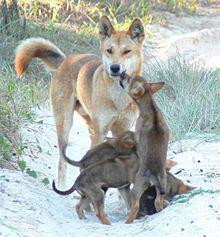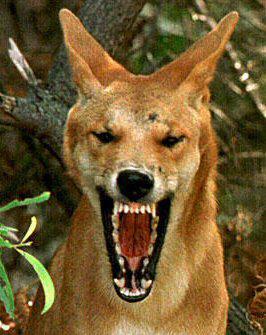The first image is the image on the left, the second image is the image on the right. Examine the images to the left and right. Is the description "The dog on the right image has its mouth wide open." accurate? Answer yes or no. Yes. 